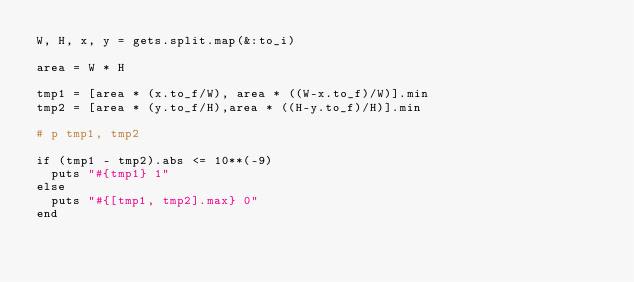Convert code to text. <code><loc_0><loc_0><loc_500><loc_500><_Ruby_>W, H, x, y = gets.split.map(&:to_i)

area = W * H

tmp1 = [area * (x.to_f/W), area * ((W-x.to_f)/W)].min
tmp2 = [area * (y.to_f/H),area * ((H-y.to_f)/H)].min

# p tmp1, tmp2

if (tmp1 - tmp2).abs <= 10**(-9)
  puts "#{tmp1} 1"
else
  puts "#{[tmp1, tmp2].max} 0"
end
</code> 